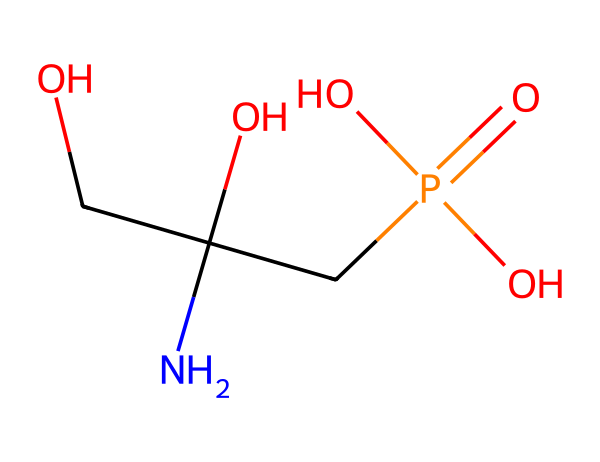What is the molecular formula of glyphosate based on the structure? By analyzing the SMILES representation, we can count the number of each type of atom present. Glyphosate contains 3 carbon (C), 4 hydrogen (H), 1 nitrogen (N), 1 phosphorus (P), and 4 oxygen (O) atoms. Therefore, the molecular formula is C3H3N2O4P.
Answer: C3H3N2O4P How many chiral centers are in glyphosate? Looking at the structure, a chiral center is typically a carbon atom connected to four different substituents. In this case, there's at least one carbon atom connected to different groups, indicating that glyphosate has one chiral center.
Answer: One What type of functional groups are present in glyphosate? Identifying functional groups based on the SMILES representation, glyphosate contains an amine group (NH2), phosphate group (PO4), and hydroxyl groups (OH). This combination indicates several functional groups are present.
Answer: Amine, phosphate, hydroxyl Which element indicates glyphosate's potential as a herbicide? The presence of phosphorus is crucial in glyphosate's structure, as it is part of the phosphate group that enhances its herbicide properties, making it effective in inhibiting plant growth.
Answer: Phosphorus What is the significance of the nitrogen atom in glyphosate's chemical structure? The nitrogen atom contributes to glyphosate's ability to interfere with specific biochemical pathways in plants, particularly those related to amino acid synthesis, thus playing a crucial role in its herbicidal action.
Answer: Interference with amino acid synthesis 